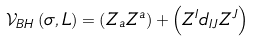<formula> <loc_0><loc_0><loc_500><loc_500>\mathcal { V } _ { B H } \left ( \sigma , L \right ) = \left ( Z _ { a } Z ^ { a } \right ) + \left ( Z ^ { I } d _ { I J } Z ^ { J } \right )</formula> 